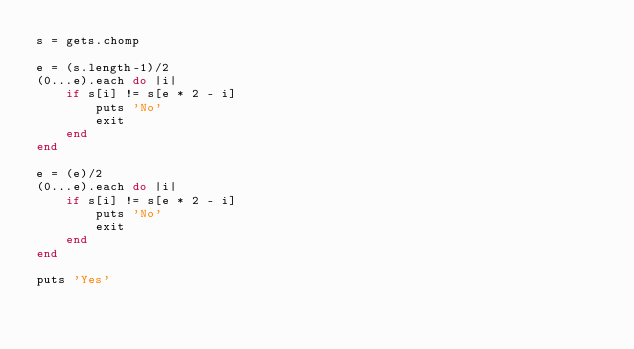<code> <loc_0><loc_0><loc_500><loc_500><_Ruby_>s = gets.chomp

e = (s.length-1)/2
(0...e).each do |i|
    if s[i] != s[e * 2 - i]
        puts 'No'
        exit
    end
end

e = (e)/2
(0...e).each do |i|
    if s[i] != s[e * 2 - i]
        puts 'No'
        exit
    end
end

puts 'Yes'
</code> 